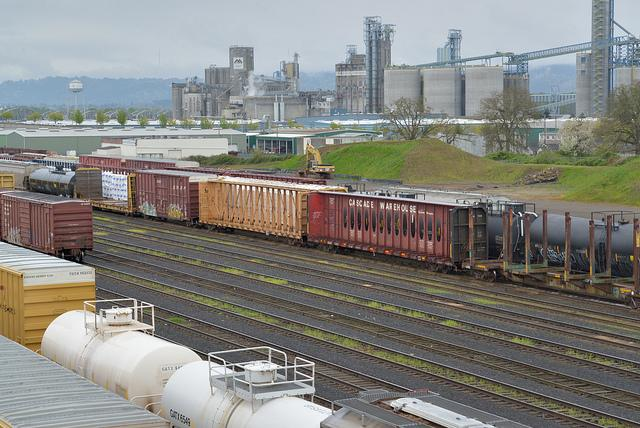What vehicles are here?

Choices:
A) trucks
B) airplanes
C) trains
D) horses trains 